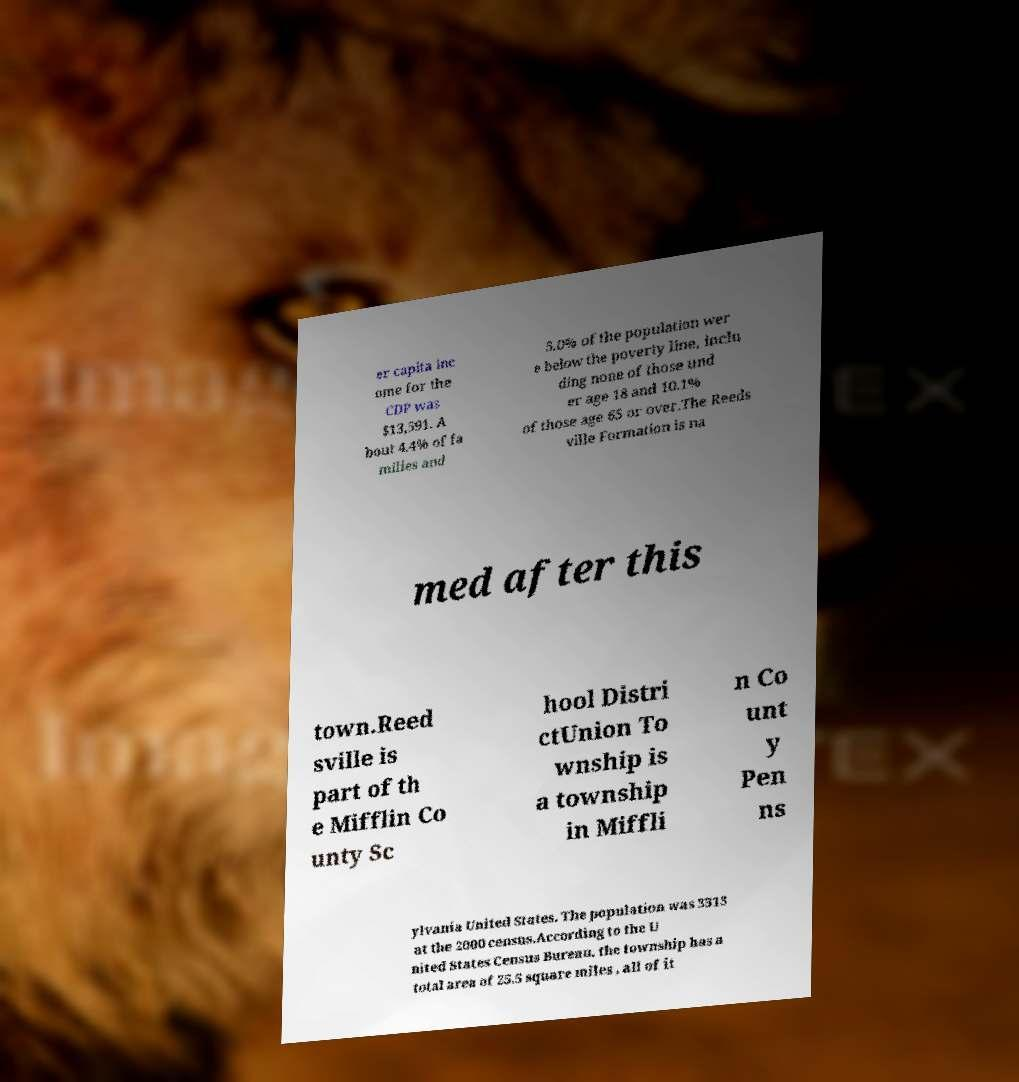For documentation purposes, I need the text within this image transcribed. Could you provide that? er capita inc ome for the CDP was $13,591. A bout 4.4% of fa milies and 5.0% of the population wer e below the poverty line, inclu ding none of those und er age 18 and 10.1% of those age 65 or over.The Reeds ville Formation is na med after this town.Reed sville is part of th e Mifflin Co unty Sc hool Distri ctUnion To wnship is a township in Miffli n Co unt y Pen ns ylvania United States. The population was 3313 at the 2000 census.According to the U nited States Census Bureau, the township has a total area of 25.5 square miles , all of it 